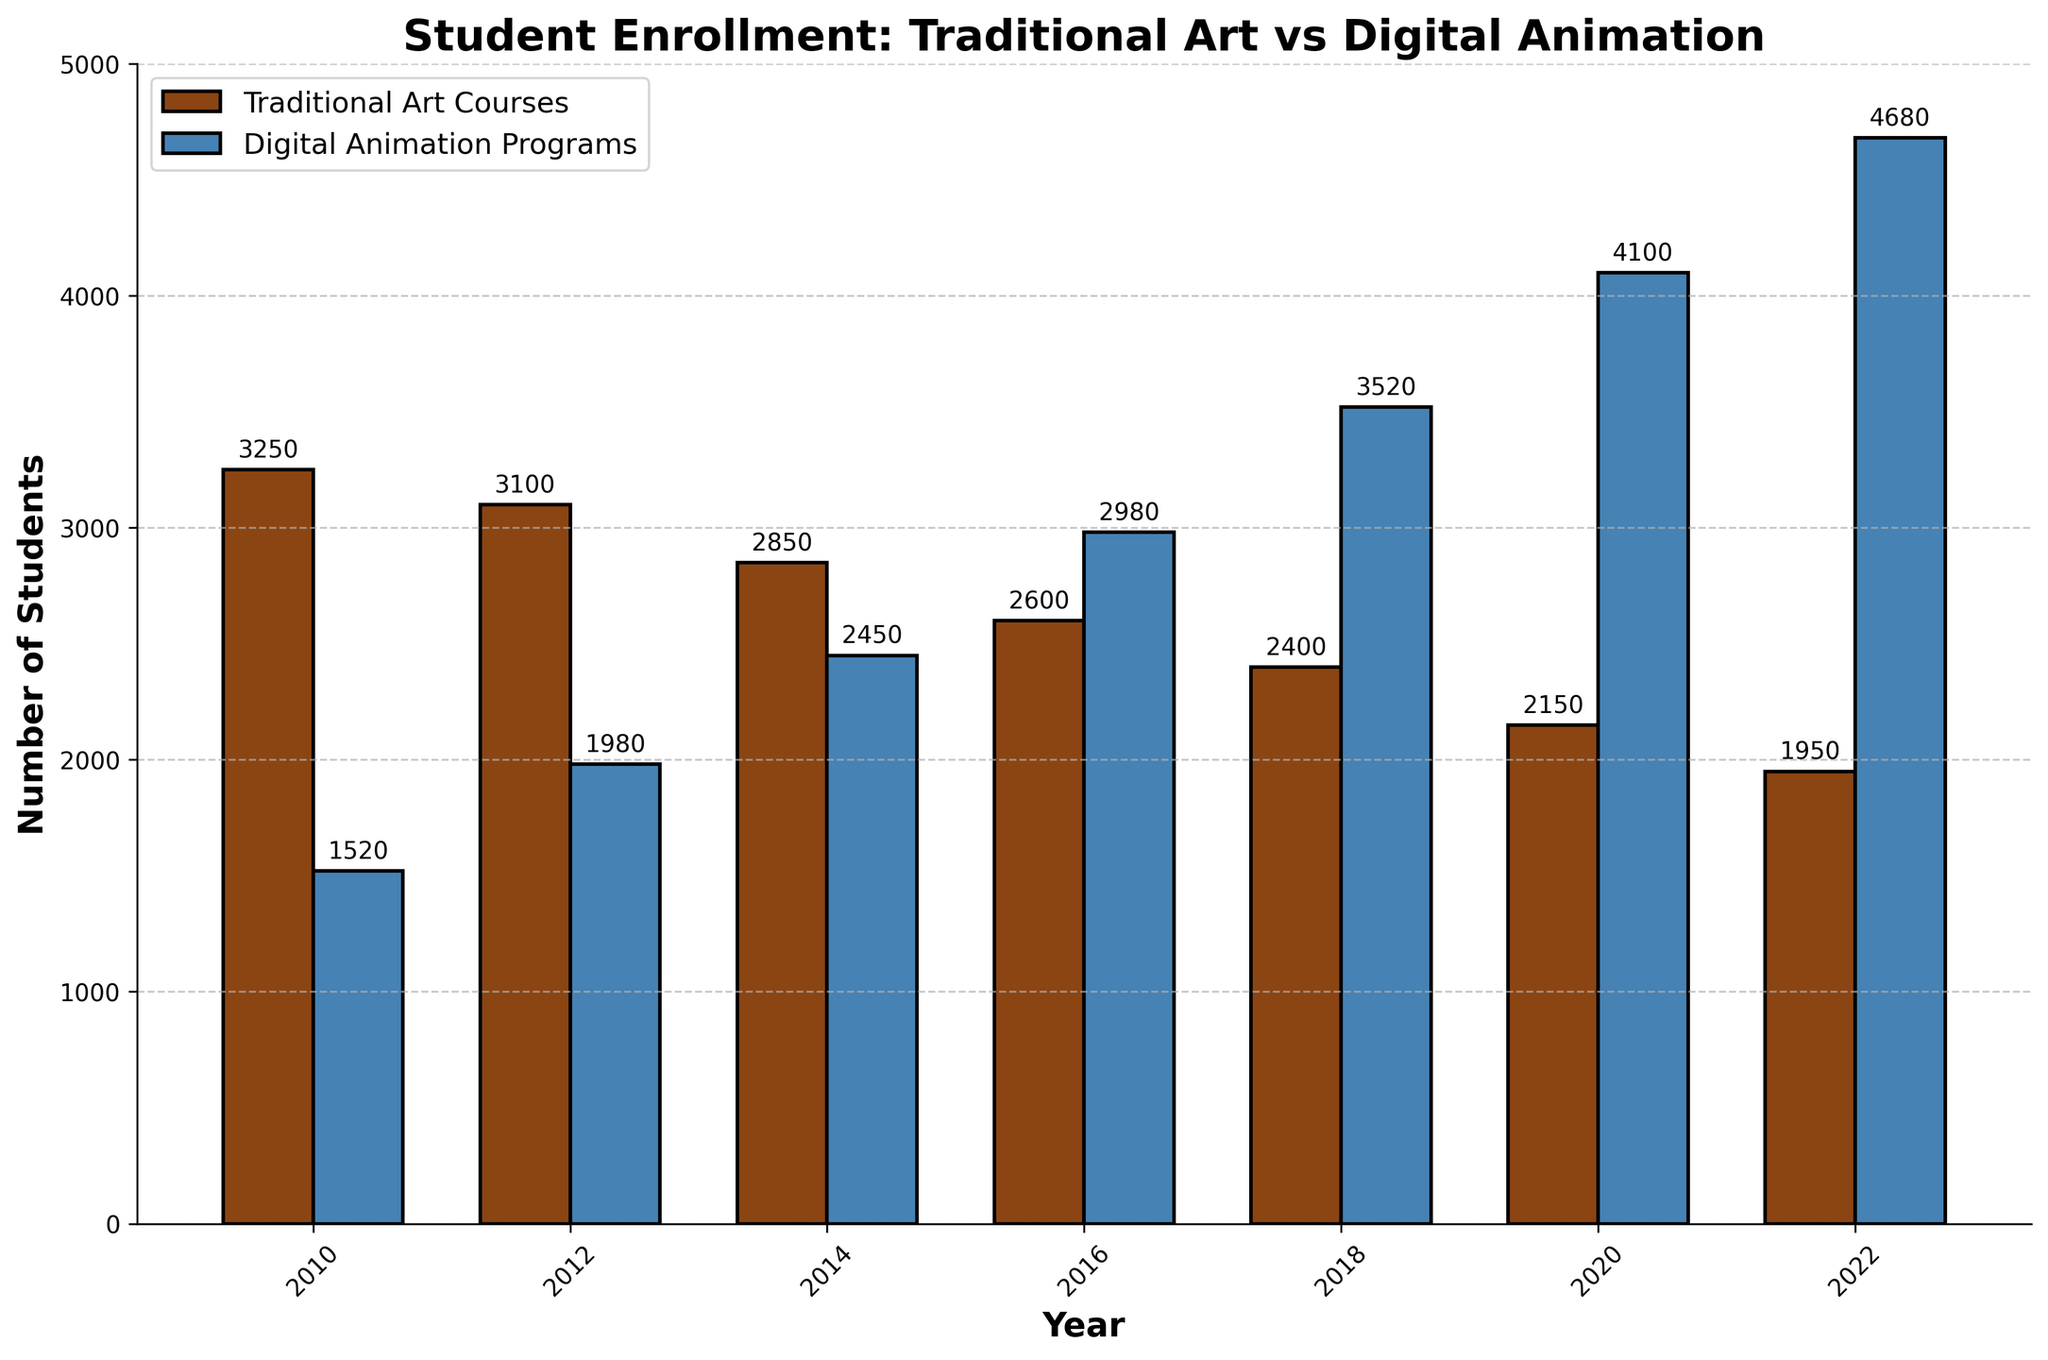What's the total enrollment in both Traditional Art Courses and Digital Animation Programs in 2022? First, identify the enrollment for Traditional Art Courses (1950) and Digital Animation Programs (4680) in 2022. Sum these values: 1950 + 4680 = 6630.
Answer: 6630 Between which consecutive years did the Digital Animation Programs see the largest growth in student enrollment? Examine the enrollment numbers for each consecutive year and calculate the differences: 
2010-2012: 1980 - 1520 = 460,
2012-2014: 2450 - 1980 = 470,
2014-2016: 2980 - 2450 = 530,
2016-2018: 3520 - 2980 = 540,
2018-2020: 4100 - 3520 = 580,
2020-2022: 4680 - 4100 = 580.
The largest growth (580) occurred between 2018-2020 and 2020-2022.
Answer: 2018-2020 and 2020-2022 Which year had the lowest total student enrollment in Traditional Art Courses? Look at the enrollment numbers for Traditional Art Courses over the years: 2010 (3250), 2012 (3100), 2014 (2850), 2016 (2600), 2018 (2400), 2020 (2150), 2022 (1950). The lowest enrollment was in 2022 with 1950 students.
Answer: 2022 By how much did the Traditional Art Courses enrollment decrease from 2010 to 2022? The enrollment in 2010 was 3250 and in 2022 it was 1950. Calculate the decrease by subtracting 1950 from 3250: 3250 - 1950 = 1300.
Answer: 1300 In which year did Digital Animation Programs surpass Traditional Art Courses in student enrollment, and by how much? Digital Animation Programs surpassed Traditional Art Courses in 2016. In 2016, the enrollments were 2980 for Digital Animation and 2600 for Traditional Art Courses. Calculate the difference: 2980 - 2600 = 380. So, 2016 with a difference of 380 students.
Answer: 2016, 380 Based on the trend observed, what can you infer about the popularity of Digital Animation Programs compared to Traditional Art Courses? Over the years, Digital Animation Programs have been increasing steadily, surpassing Traditional Art Courses in 2016. Meanwhile, Traditional Art Courses have seen a continuous decline from 3250 in 2010 to 1950 in 2022. This suggests a growing preference for Digital Animation Programs among students.
Answer: Digital Animation Programs are becoming more popular while Traditional Art Courses are declining 